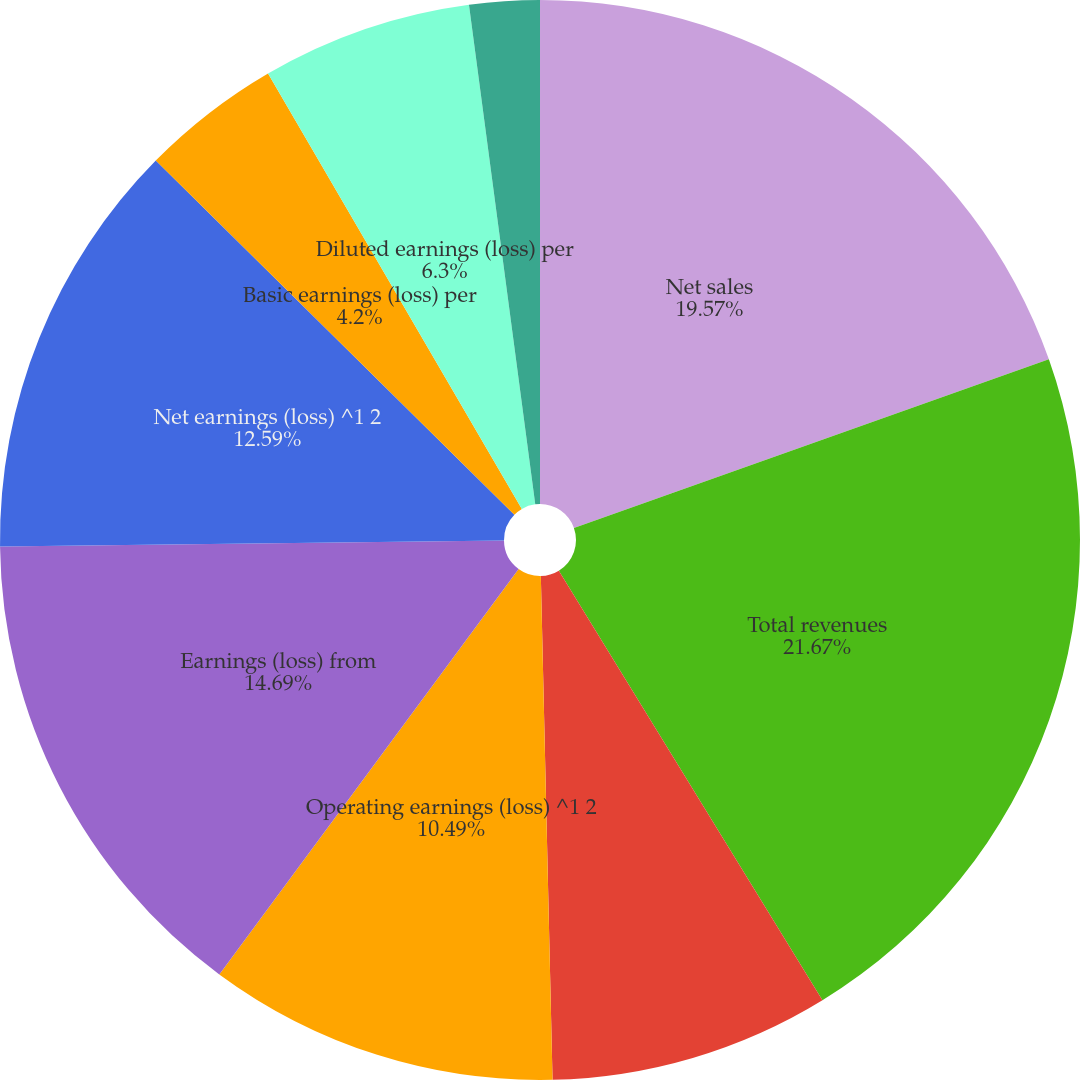Convert chart to OTSL. <chart><loc_0><loc_0><loc_500><loc_500><pie_chart><fcel>Net sales<fcel>Total revenues<fcel>Gross profit<fcel>Operating earnings (loss) ^1 2<fcel>Earnings (loss) from<fcel>Net earnings (loss) ^1 2<fcel>Basic earnings (loss) per<fcel>Diluted earnings (loss) per<fcel>Basic net earnings (loss) per<fcel>Diluted net earnings (loss)<nl><fcel>19.57%<fcel>21.67%<fcel>8.39%<fcel>10.49%<fcel>14.69%<fcel>12.59%<fcel>4.2%<fcel>6.3%<fcel>0.0%<fcel>2.1%<nl></chart> 